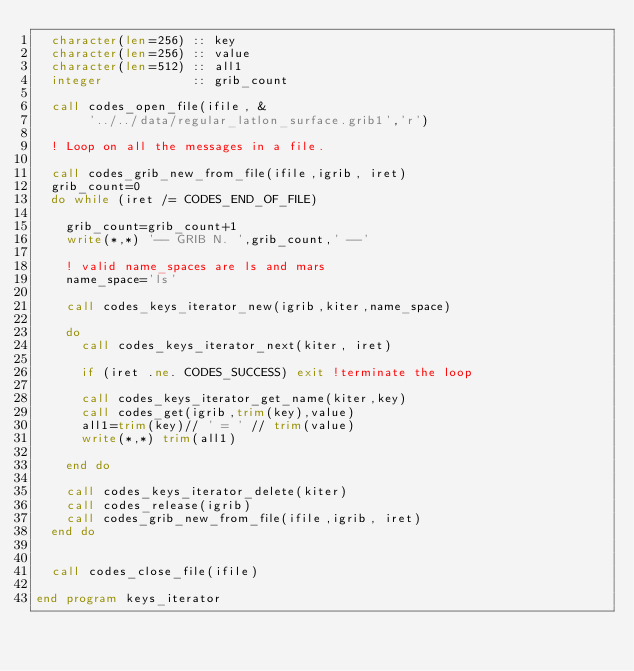<code> <loc_0><loc_0><loc_500><loc_500><_FORTRAN_>  character(len=256) :: key
  character(len=256) :: value
  character(len=512) :: all1
  integer            :: grib_count

  call codes_open_file(ifile, &
       '../../data/regular_latlon_surface.grib1','r')

  ! Loop on all the messages in a file.

  call codes_grib_new_from_file(ifile,igrib, iret)
  grib_count=0
  do while (iret /= CODES_END_OF_FILE)

    grib_count=grib_count+1
    write(*,*) '-- GRIB N. ',grib_count,' --'

    ! valid name_spaces are ls and mars
    name_space='ls'

    call codes_keys_iterator_new(igrib,kiter,name_space)

    do
      call codes_keys_iterator_next(kiter, iret)

      if (iret .ne. CODES_SUCCESS) exit !terminate the loop

      call codes_keys_iterator_get_name(kiter,key)
      call codes_get(igrib,trim(key),value)
      all1=trim(key)// ' = ' // trim(value)
      write(*,*) trim(all1)

    end do

    call codes_keys_iterator_delete(kiter)
    call codes_release(igrib)
    call codes_grib_new_from_file(ifile,igrib, iret)
  end do


  call codes_close_file(ifile)

end program keys_iterator
</code> 